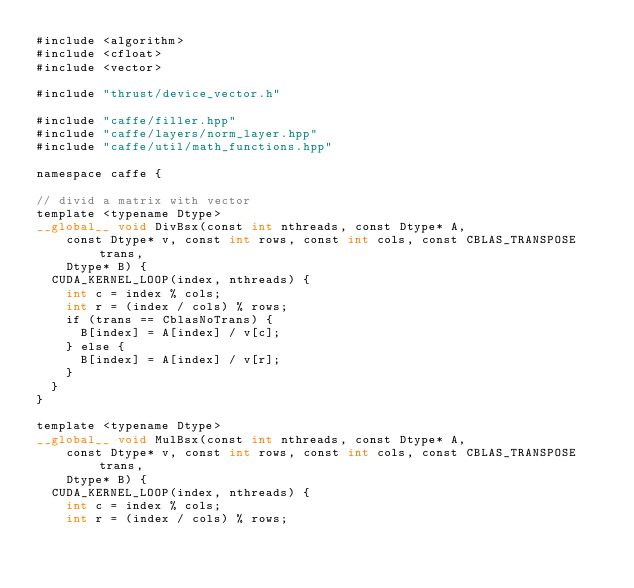<code> <loc_0><loc_0><loc_500><loc_500><_Cuda_>#include <algorithm>
#include <cfloat>
#include <vector>

#include "thrust/device_vector.h"

#include "caffe/filler.hpp"
#include "caffe/layers/norm_layer.hpp"
#include "caffe/util/math_functions.hpp"

namespace caffe {

// divid a matrix with vector
template <typename Dtype>
__global__ void DivBsx(const int nthreads, const Dtype* A,
    const Dtype* v, const int rows, const int cols, const CBLAS_TRANSPOSE trans,
    Dtype* B) {
  CUDA_KERNEL_LOOP(index, nthreads) {
    int c = index % cols;
    int r = (index / cols) % rows;
    if (trans == CblasNoTrans) {
      B[index] = A[index] / v[c];
    } else {
      B[index] = A[index] / v[r];
    }
  }
}

template <typename Dtype>
__global__ void MulBsx(const int nthreads, const Dtype* A,
    const Dtype* v, const int rows, const int cols, const CBLAS_TRANSPOSE trans,
    Dtype* B) {
  CUDA_KERNEL_LOOP(index, nthreads) {
    int c = index % cols;
    int r = (index / cols) % rows;</code> 